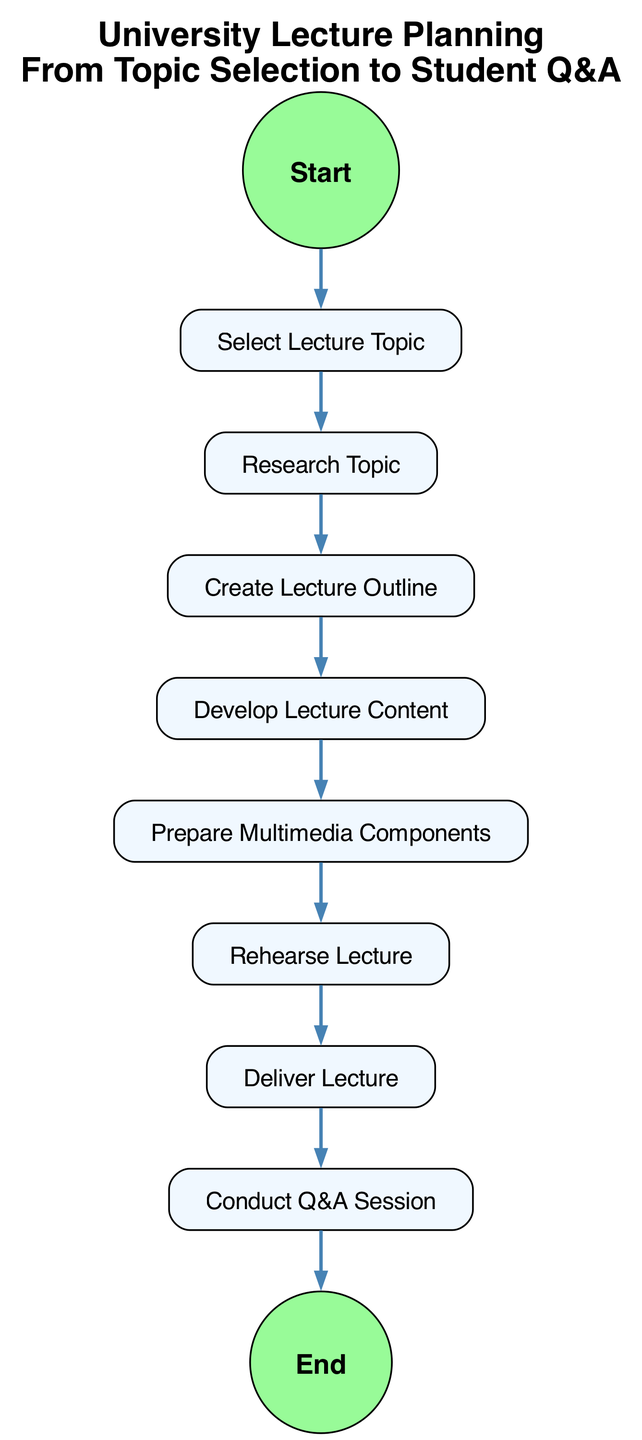What is the first activity in the diagram? The first activity is represented by the "Start" node, indicating the beginning of the lecture planning process.
Answer: Start How many tasks are present in the diagram? The diagram includes a total of 8 tasks, which are distinct activities between the start and the end events.
Answer: 8 What is the last activity before the end event? The last activity before reaching the end is "Conduct Q&A Session," which concludes the lecture planning process.
Answer: Conduct Q&A Session Which task directly follows "Research Topic"? "Create Lecture Outline" is the task that immediately follows "Research Topic," indicating the next step in the planning process.
Answer: Create Lecture Outline How many transitions are there in total in the diagram? There are 9 transitions, which represent the flow from one activity to another throughout the lecture planning process.
Answer: 9 What type of diagram is represented here? This diagram is an Activity Diagram, designed to visualize the sequential flow of activities in planning a university lecture.
Answer: Activity Diagram What is the relationship between "Deliver Lecture" and "Conduct Q&A Session"? "Deliver Lecture" directly leads to "Conduct Q&A Session," indicating a sequential flow where the lecture is presented before the Q&A takes place.
Answer: Directly leads to What is the main purpose of this diagram? The main purpose of this diagram is to outline the steps involved in planning a university lecture, from topic selection to the Q&A session.
Answer: Outline the steps What activity comes after "Prepare Multimedia Components"? "Rehearse Lecture" is the activity that follows "Prepare Multimedia Components," demonstrating preparation for the delivery of the lecture.
Answer: Rehearse Lecture 